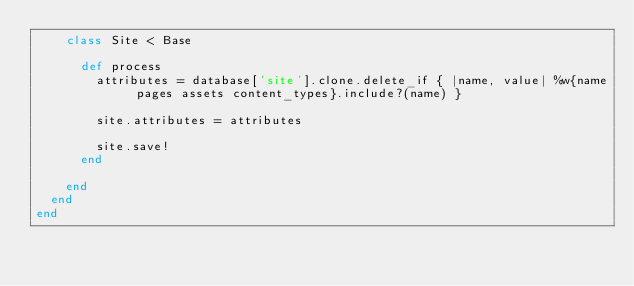Convert code to text. <code><loc_0><loc_0><loc_500><loc_500><_Ruby_>    class Site < Base

      def process
        attributes = database['site'].clone.delete_if { |name, value| %w{name pages assets content_types}.include?(name) }

        site.attributes = attributes

        site.save!
      end

    end
  end
end</code> 